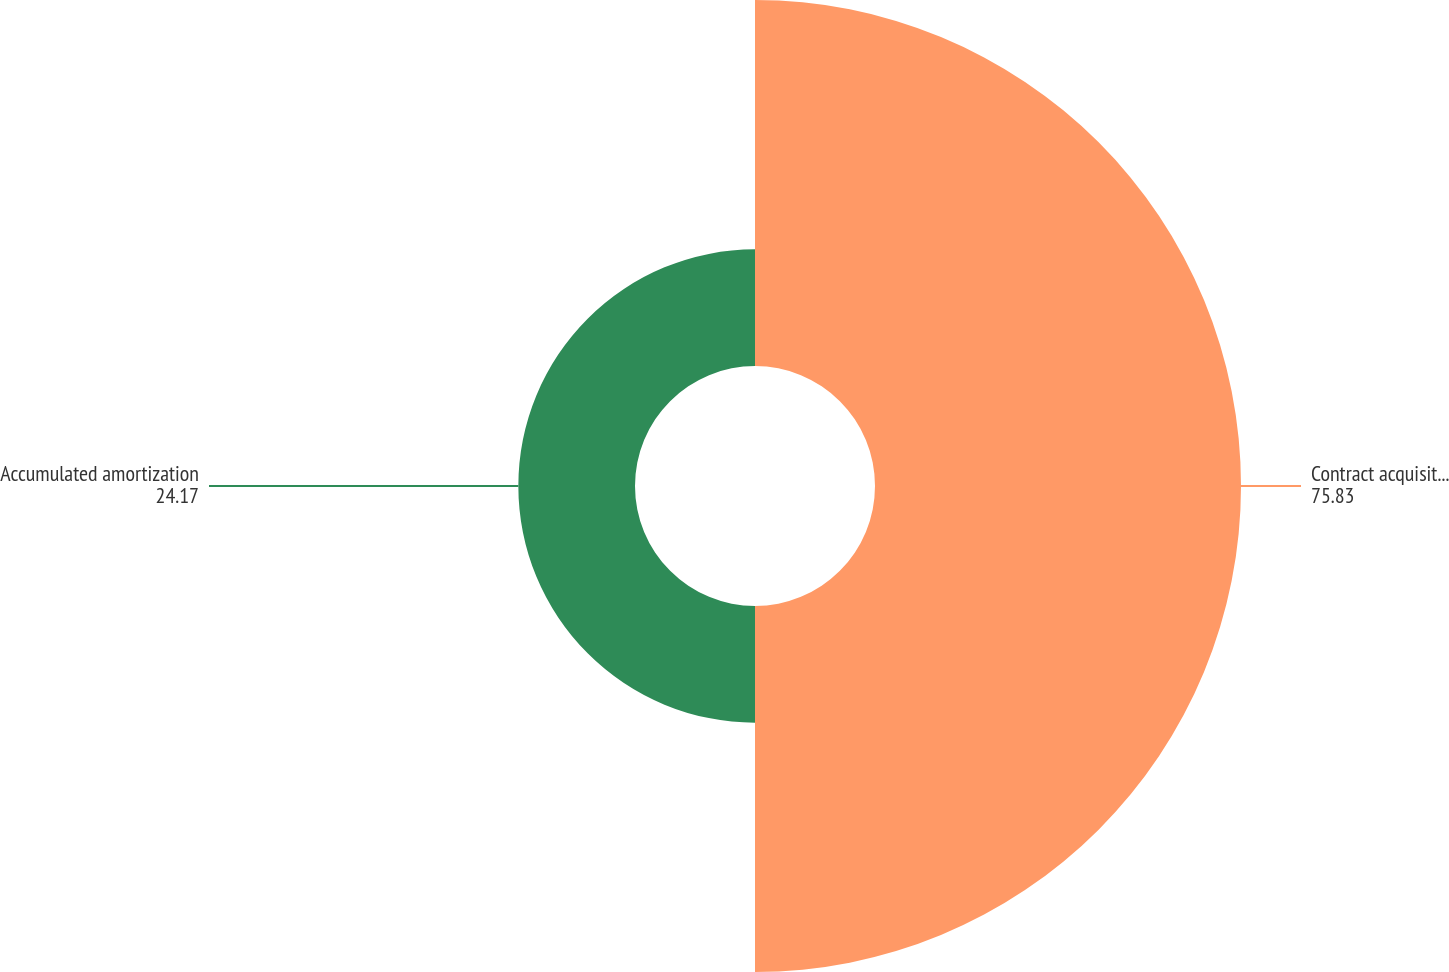Convert chart. <chart><loc_0><loc_0><loc_500><loc_500><pie_chart><fcel>Contract acquisition costs and<fcel>Accumulated amortization<nl><fcel>75.83%<fcel>24.17%<nl></chart> 